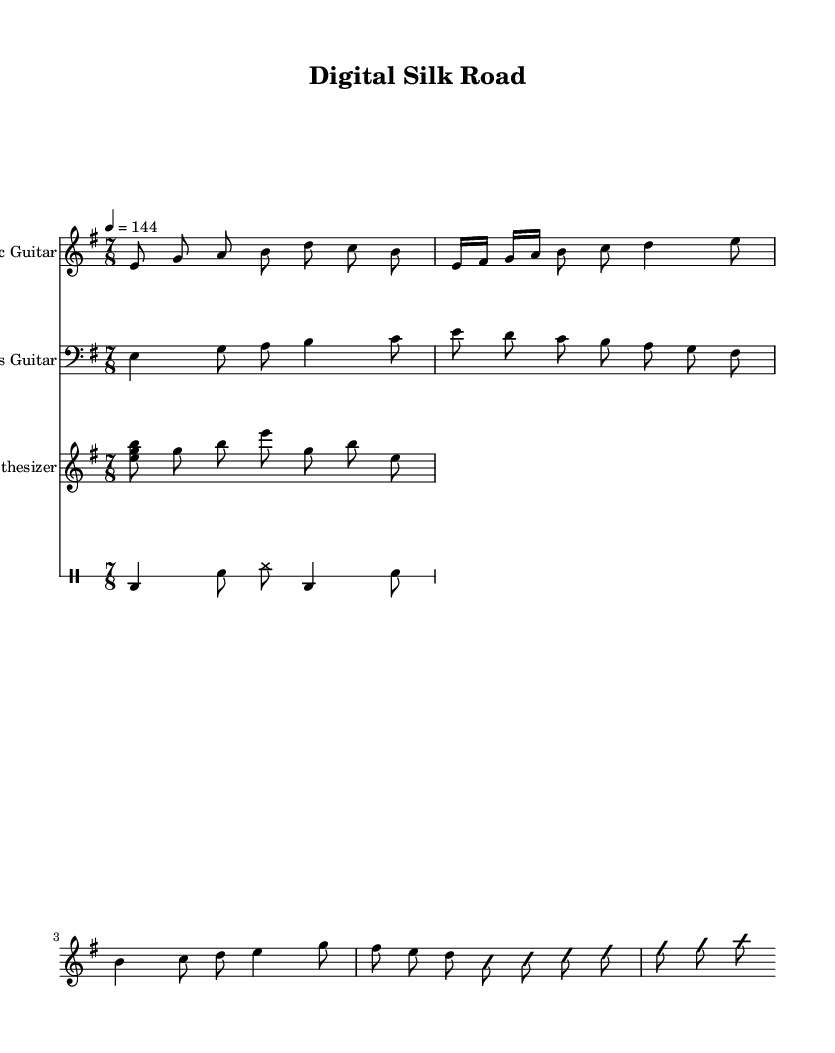What is the key signature of this music? The key signature is E minor, which has one sharp (F#). This can be determined by looking at the key indicated at the beginning of the music.
Answer: E minor What is the time signature of this music? The time signature is 7/8, which is indicated at the beginning of the score. This means there are seven eighth notes per measure.
Answer: 7/8 What is the tempo marking of this music? The tempo marking indicates 144 beats per minute, which shows how fast the piece should be played. This is located near the beginning of the score.
Answer: 144 What instrument is playing the main riff? The main riff is played by the Electric Guitar, as indicated by the instrument name at the beginning of the staff.
Answer: Electric Guitar How many measures are there in the solo section? The solo section consists of 4 measures as indicated by the improvisation section in the Electric Guitar part. Each measure is marked by the rhythmic grouping.
Answer: 4 What instrument plays the bridge section? The bridge section is played by the Bass Guitar, clearly labeled on the staff with its instrument name. The section is identified by its unique melody pattern compared to other parts.
Answer: Bass Guitar What is the highest note played in the synthesizer part? The highest note in the synthesizer part is B, which is the highest pitch in the arpeggiated Em chord sequence written at the beginning of the Synthesizer’s line.
Answer: B 